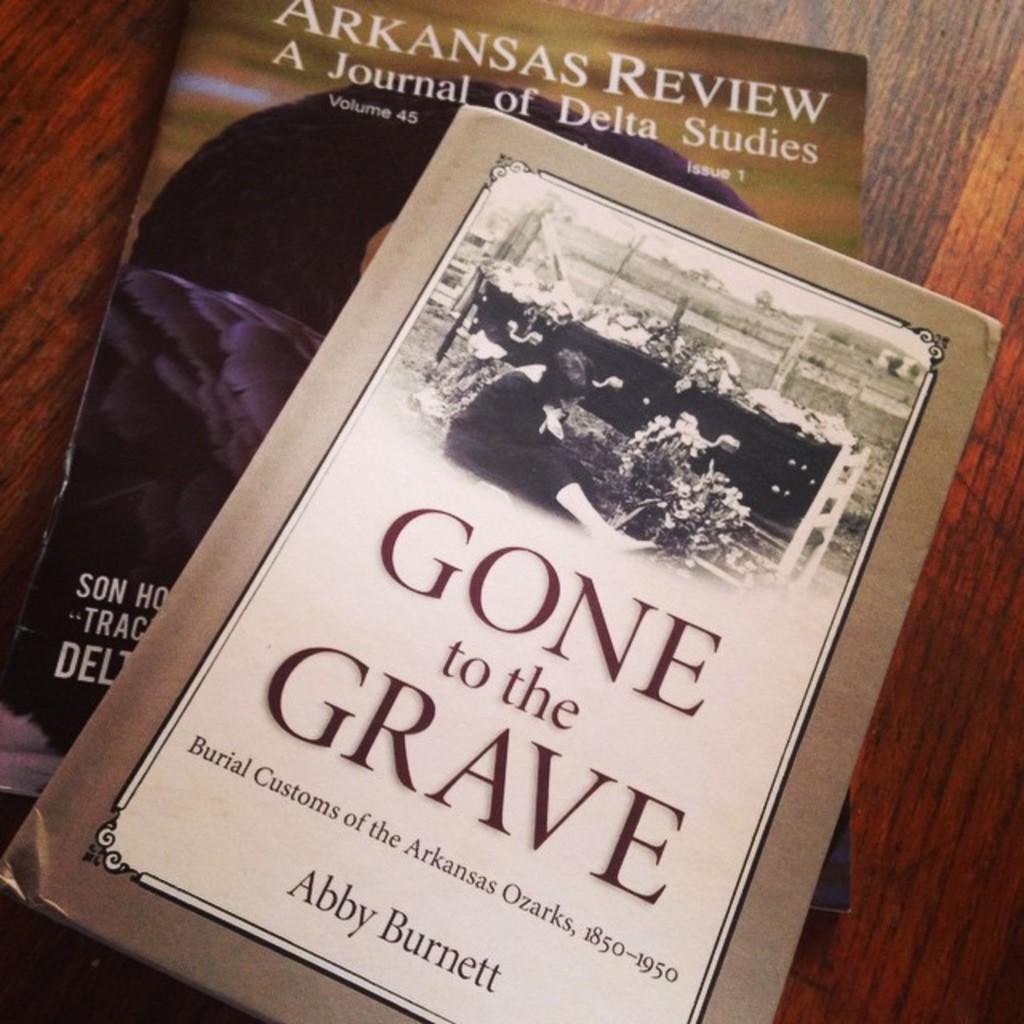What is the book title?
Give a very brief answer. Gone to the grave. 